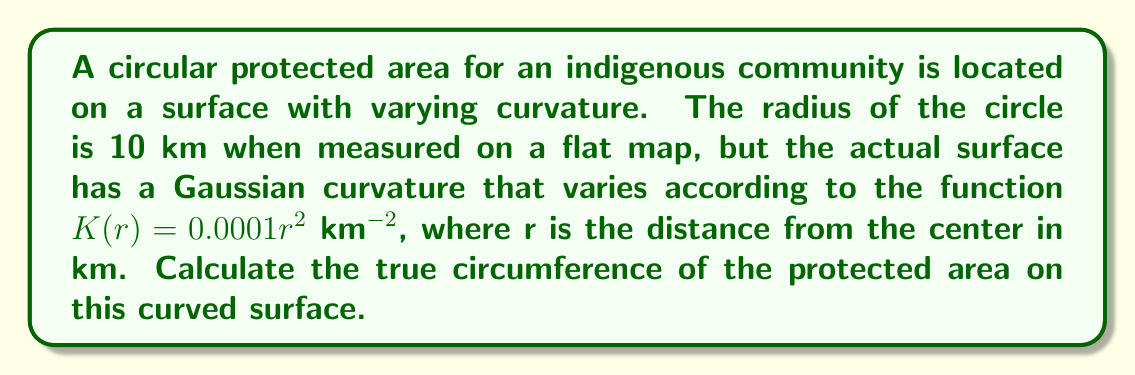Provide a solution to this math problem. To solve this problem, we need to use concepts from non-Euclidean geometry, specifically for surfaces with varying curvature. Here's a step-by-step approach:

1) In non-Euclidean geometry, the circumference of a circle on a curved surface is given by the integral:

   $$C = \int_0^{2\pi} \sqrt{g_{\theta\theta}} d\theta$$

   where $g_{\theta\theta}$ is the metric tensor component for the angular coordinate.

2) For a surface with radially symmetric curvature, we can express $g_{\theta\theta}$ as:

   $$g_{\theta\theta} = r^2 \cdot f(r)$$

   where $f(r)$ is a function that depends on the curvature of the surface.

3) For small curvatures, we can approximate $f(r)$ as:

   $$f(r) \approx 1 - \frac{1}{6}K(r)r^2$$

4) Substituting the given curvature function $K(r) = 0.0001r^2$:

   $$f(r) \approx 1 - \frac{1}{6} \cdot 0.0001r^2 \cdot r^2 = 1 - \frac{1}{60000}r^4$$

5) Now, $g_{\theta\theta} = r^2 \cdot (1 - \frac{1}{60000}r^4)$

6) The circumference integral becomes:

   $$C = \int_0^{2\pi} \sqrt{r^2 \cdot (1 - \frac{1}{60000}r^4)} d\theta$$

7) Since $r$ is constant (10 km), we can simplify:

   $$C = 2\pi r \sqrt{1 - \frac{1}{60000}r^4}$$

8) Substituting $r = 10$ km:

   $$C = 2\pi \cdot 10 \cdot \sqrt{1 - \frac{1}{60000} \cdot 10^4}$$

9) Simplifying:

   $$C = 20\pi \cdot \sqrt{1 - \frac{1}{6}} = 20\pi \cdot \sqrt{\frac{5}{6}}$$

10) Calculating the final value:

    $$C \approx 62.035 \text{ km}$$
Answer: $62.035 \text{ km}$ 